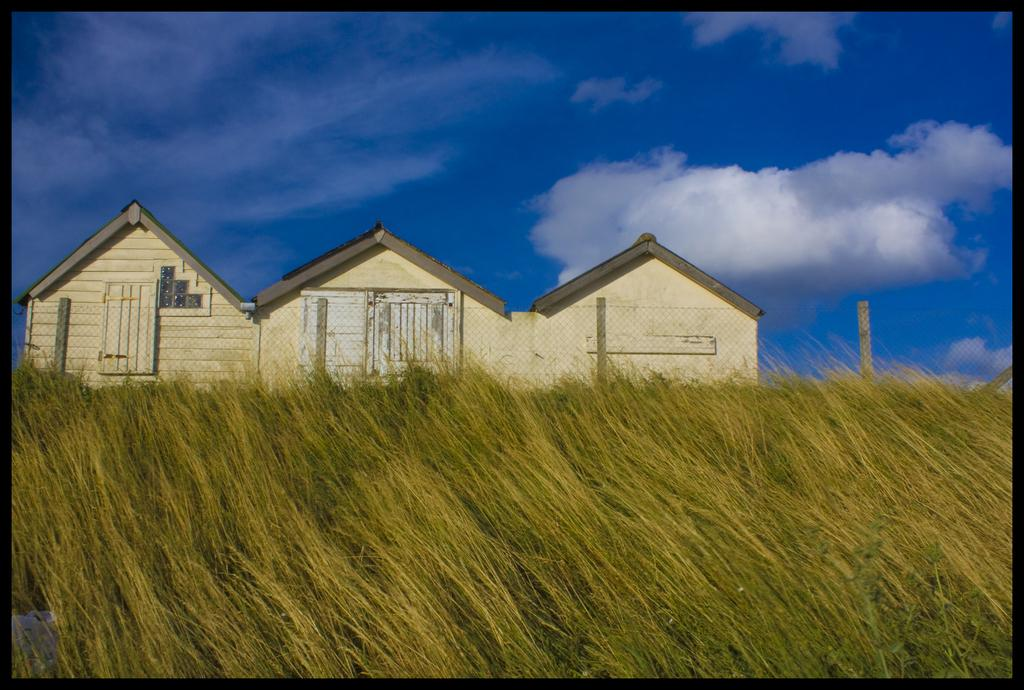What type of structures are visible in the image? There are houses with roofs in the image. What material are some of the poles made of? There are wooden poles in the image. What type of barrier is present in the image? There is a metal fence in the image. What can be seen above the structures and poles in the image? The sky is visible in the image. How would you describe the weather based on the appearance of the sky? The sky appears to be cloudy in the image. What is the chance of winning a lottery in the image? There is no information about a lottery or winning chances in the image. 